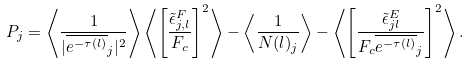Convert formula to latex. <formula><loc_0><loc_0><loc_500><loc_500>P _ { j } = \left \langle \frac { 1 } { | \overline { e ^ { - \tau ( l ) } } _ { j } | ^ { 2 } } \right \rangle \left \langle \left [ \frac { \tilde { \epsilon } ^ { F } _ { j , l } } { F _ { c } } \right ] ^ { 2 } \right \rangle - \left \langle \frac { 1 } { N ( l ) _ { j } } \right \rangle - \left \langle \left [ \frac { \tilde { \epsilon } ^ { E } _ { j l } } { F _ { c } \overline { e ^ { - \tau ( l ) } } _ { j } } \right ] ^ { 2 } \right \rangle .</formula> 